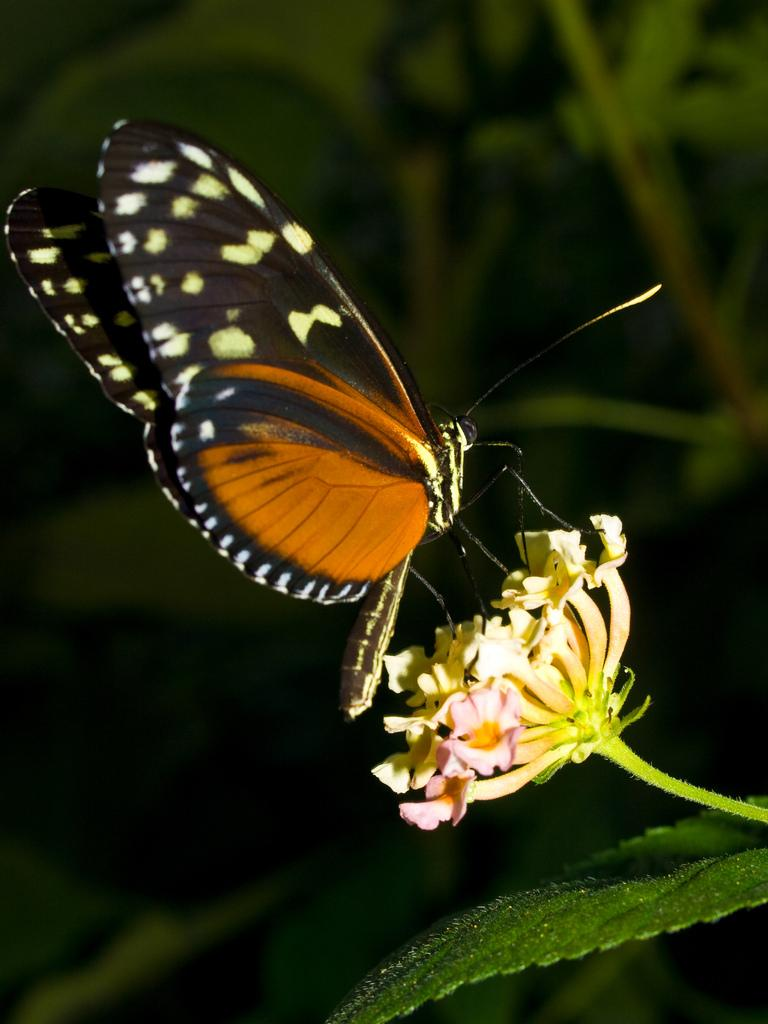What is the main subject of the image? There is a flower in the image. What is on the flower? A butterfly is standing on the flower. What is below the flower? There is a leaf below the flower. What can be seen in the background of the image? There are plants in the background of the image. What event is the son attending in the image? There is no event or son present in the image; it features a flower with a butterfly on it and a leaf below it. Can you tell me how many thumbs are visible in the image? There are no thumbs visible in the image. 